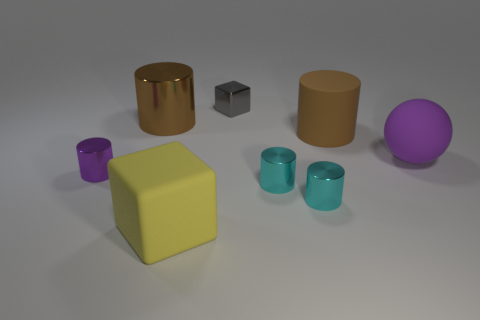Subtract all rubber cylinders. How many cylinders are left? 4 Add 2 tiny yellow metallic cylinders. How many objects exist? 10 Subtract all yellow blocks. How many blocks are left? 1 Subtract all yellow blocks. How many brown cylinders are left? 2 Subtract all spheres. How many objects are left? 7 Subtract 2 blocks. How many blocks are left? 0 Subtract all brown objects. Subtract all big red objects. How many objects are left? 6 Add 6 small gray metallic cubes. How many small gray metallic cubes are left? 7 Add 6 big red shiny spheres. How many big red shiny spheres exist? 6 Subtract 1 yellow blocks. How many objects are left? 7 